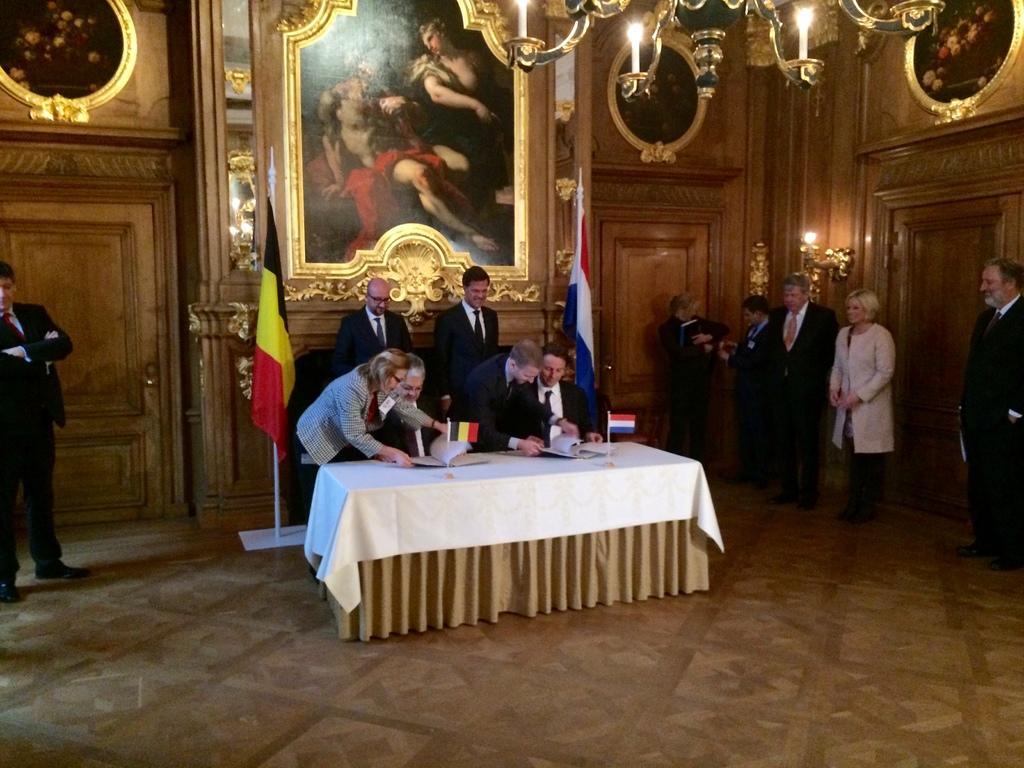How would you summarize this image in a sentence or two? in the center we can see few persons were standing around the table. On table,we can see flag,book,cloth. And on the right we can see few persons were standing. And on the left we can see one man standing. And coming to back we can see wall,light,door,flags. 